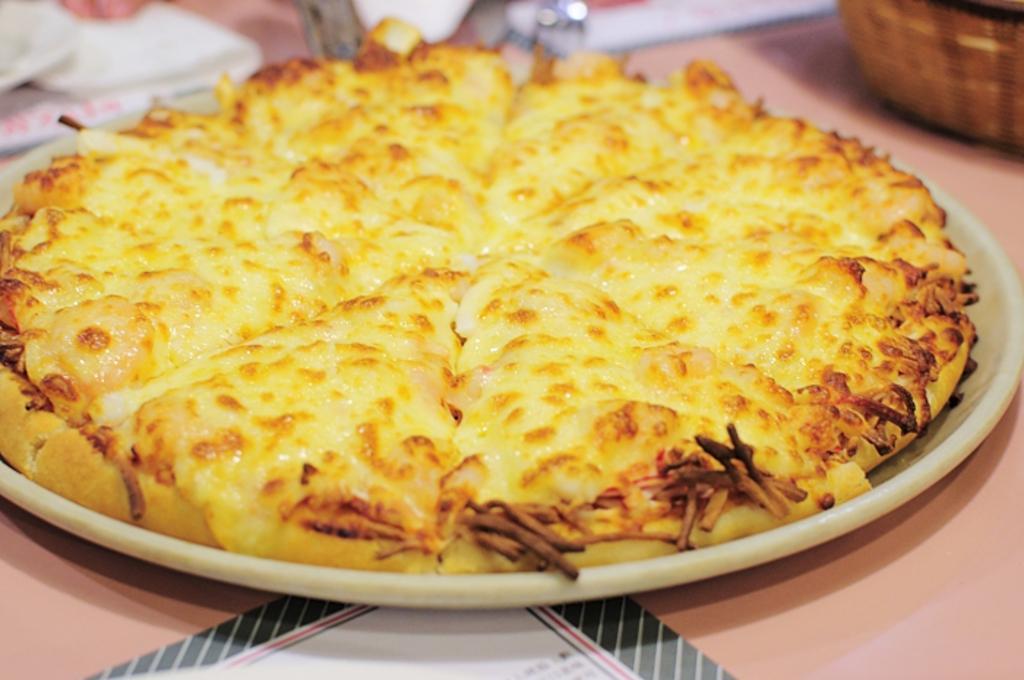How would you summarize this image in a sentence or two? In this picture there is a food on the plate. At the back there objects and there is a basket and there is a paper on the table. 